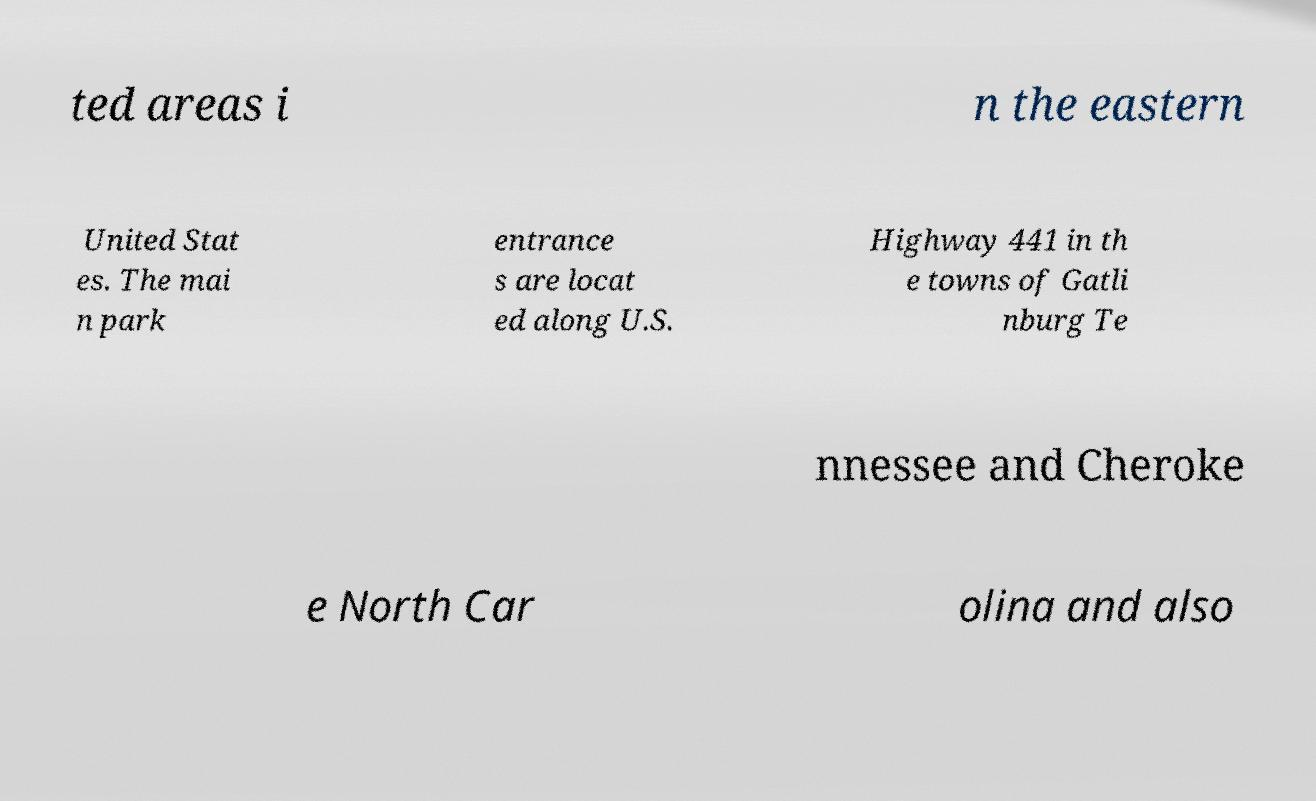Please read and relay the text visible in this image. What does it say? ted areas i n the eastern United Stat es. The mai n park entrance s are locat ed along U.S. Highway 441 in th e towns of Gatli nburg Te nnessee and Cheroke e North Car olina and also 